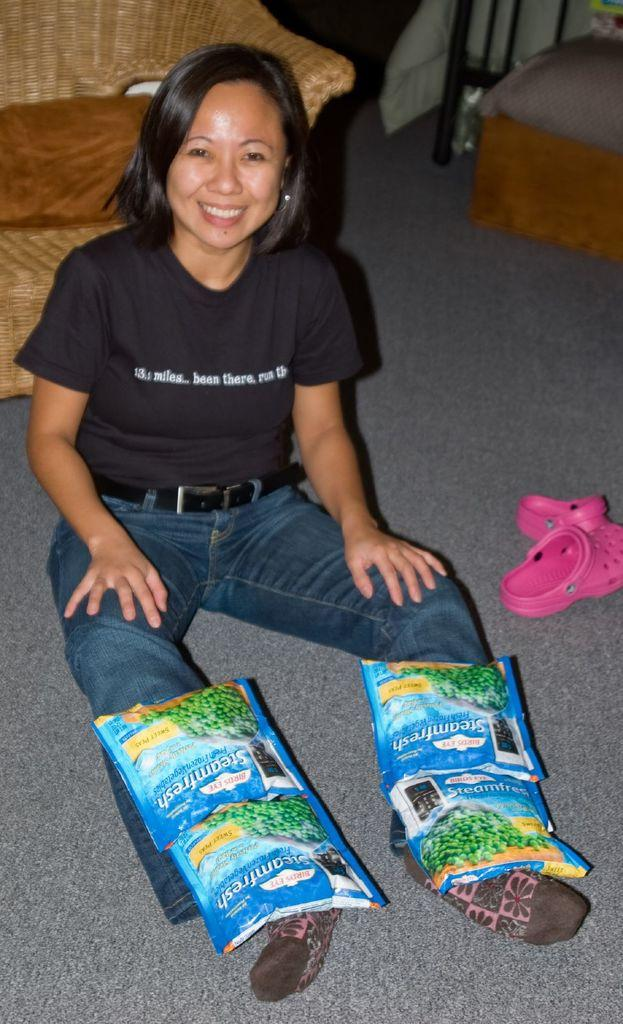What is the woman in the image doing? The woman is sitting on the floor in the image. What is on the woman's legs? The woman has packets on her legs. What can be seen in the background of the image? There is a sofa in the background of the image. How much does the boy weigh in the image? There is no boy present in the image, so it is not possible to determine his weight. 